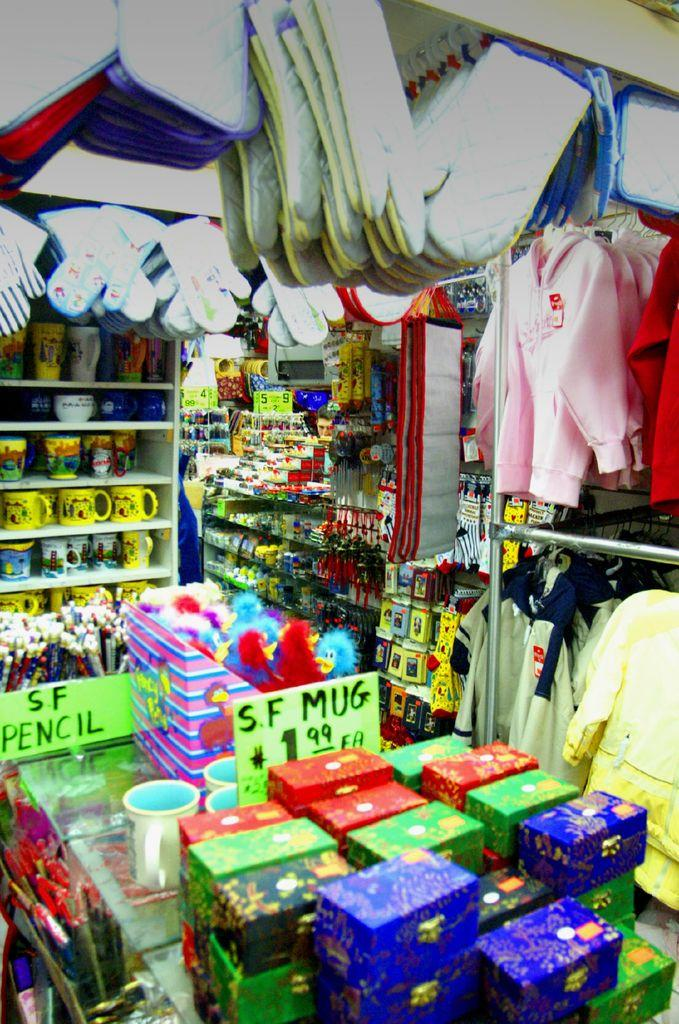<image>
Share a concise interpretation of the image provided. the word mug is on the front of a green sign 